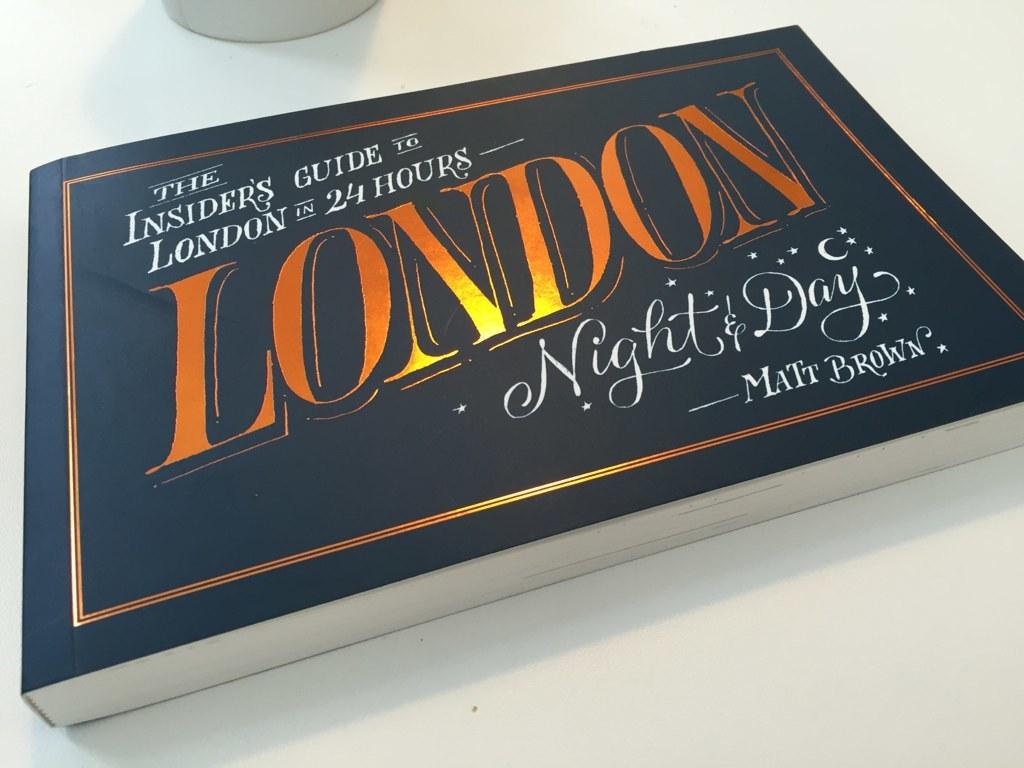Where can you use this book?
Your answer should be very brief. London. 